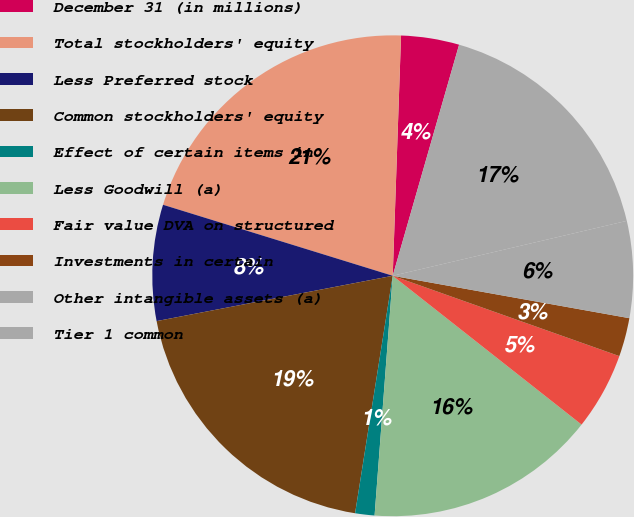Convert chart to OTSL. <chart><loc_0><loc_0><loc_500><loc_500><pie_chart><fcel>December 31 (in millions)<fcel>Total stockholders' equity<fcel>Less Preferred stock<fcel>Common stockholders' equity<fcel>Effect of certain items in<fcel>Less Goodwill (a)<fcel>Fair value DVA on structured<fcel>Investments in certain<fcel>Other intangible assets (a)<fcel>Tier 1 common<nl><fcel>3.9%<fcel>20.78%<fcel>7.79%<fcel>19.48%<fcel>1.3%<fcel>15.58%<fcel>5.2%<fcel>2.6%<fcel>6.49%<fcel>16.88%<nl></chart> 